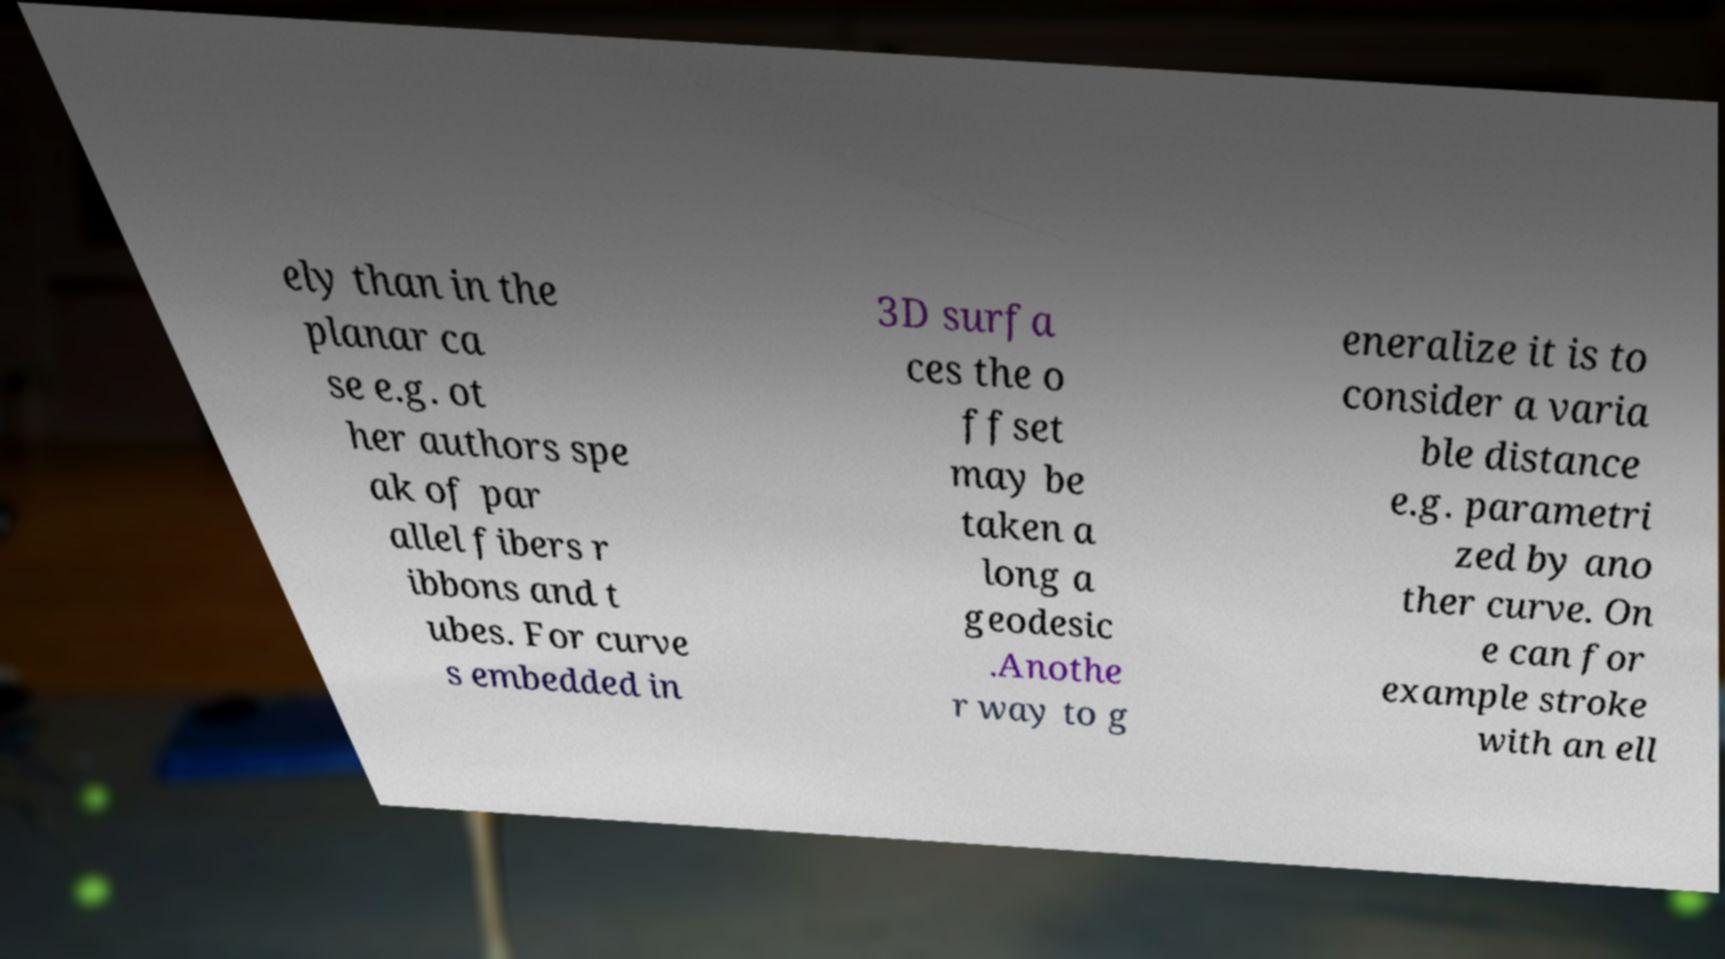There's text embedded in this image that I need extracted. Can you transcribe it verbatim? ely than in the planar ca se e.g. ot her authors spe ak of par allel fibers r ibbons and t ubes. For curve s embedded in 3D surfa ces the o ffset may be taken a long a geodesic .Anothe r way to g eneralize it is to consider a varia ble distance e.g. parametri zed by ano ther curve. On e can for example stroke with an ell 